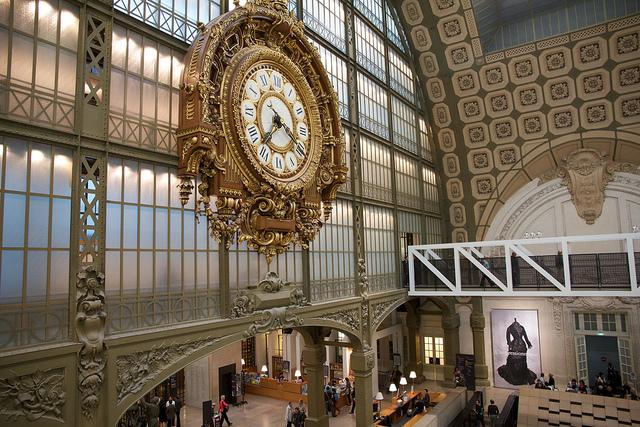What is on the advertisement overlooked by the gold clock?

Choices:
A) watch
B) dress
C) food
D) perfume dress 